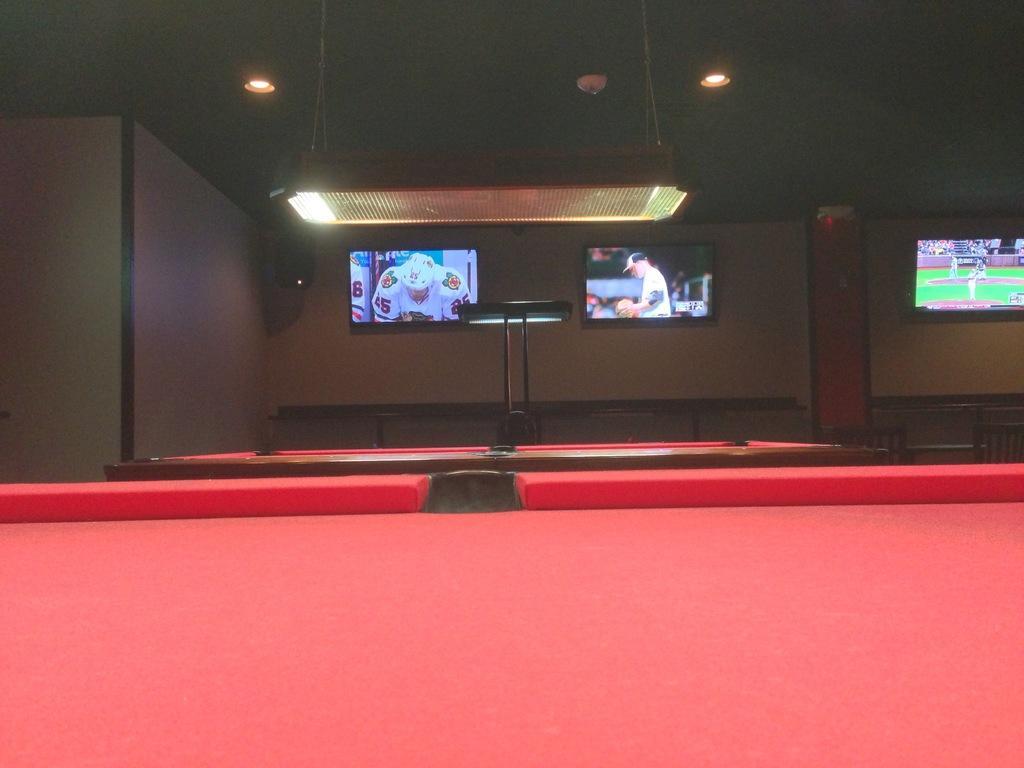How would you summarize this image in a sentence or two? In this image I can see a three television and light and alight. In front there is red table. 